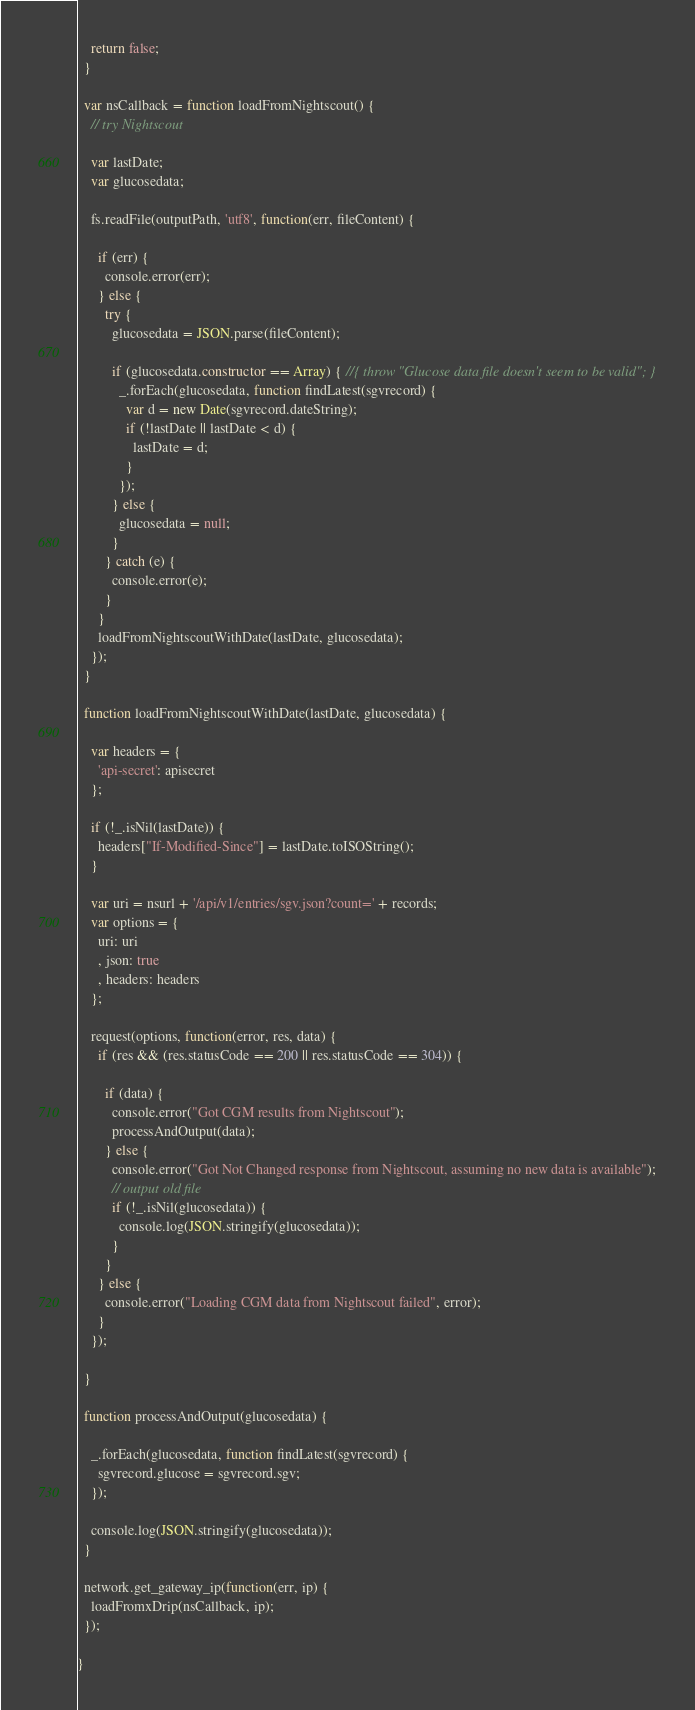<code> <loc_0><loc_0><loc_500><loc_500><_JavaScript_>    return false;
  }

  var nsCallback = function loadFromNightscout() {
    // try Nightscout

    var lastDate;
    var glucosedata;

    fs.readFile(outputPath, 'utf8', function(err, fileContent) {

      if (err) {
        console.error(err);
      } else {
        try {
          glucosedata = JSON.parse(fileContent);

          if (glucosedata.constructor == Array) { //{ throw "Glucose data file doesn't seem to be valid"; }
            _.forEach(glucosedata, function findLatest(sgvrecord) {
              var d = new Date(sgvrecord.dateString);
              if (!lastDate || lastDate < d) {
                lastDate = d;
              }
            });
          } else {
            glucosedata = null;
          }
        } catch (e) {
          console.error(e);
        }
      }
      loadFromNightscoutWithDate(lastDate, glucosedata);
    });
  }

  function loadFromNightscoutWithDate(lastDate, glucosedata) {

    var headers = {
      'api-secret': apisecret
    };

    if (!_.isNil(lastDate)) {
      headers["If-Modified-Since"] = lastDate.toISOString();
    }

    var uri = nsurl + '/api/v1/entries/sgv.json?count=' + records;
    var options = {
      uri: uri
      , json: true
      , headers: headers
    };

    request(options, function(error, res, data) {
      if (res && (res.statusCode == 200 || res.statusCode == 304)) {

        if (data) {
          console.error("Got CGM results from Nightscout");
          processAndOutput(data);
        } else {
          console.error("Got Not Changed response from Nightscout, assuming no new data is available");
          // output old file
          if (!_.isNil(glucosedata)) {
            console.log(JSON.stringify(glucosedata));
          }
        }
      } else {
        console.error("Loading CGM data from Nightscout failed", error);
      }
    });

  }

  function processAndOutput(glucosedata) {

    _.forEach(glucosedata, function findLatest(sgvrecord) {
      sgvrecord.glucose = sgvrecord.sgv;
    });

    console.log(JSON.stringify(glucosedata));
  }

  network.get_gateway_ip(function(err, ip) {
    loadFromxDrip(nsCallback, ip);
  });

}
</code> 